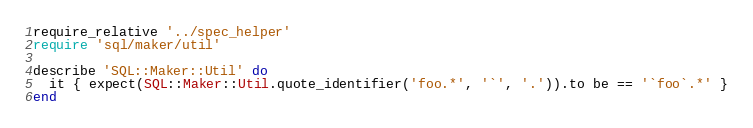Convert code to text. <code><loc_0><loc_0><loc_500><loc_500><_Ruby_>require_relative '../spec_helper'
require 'sql/maker/util'

describe 'SQL::Maker::Util' do
  it { expect(SQL::Maker::Util.quote_identifier('foo.*', '`', '.')).to be == '`foo`.*' }
end
</code> 